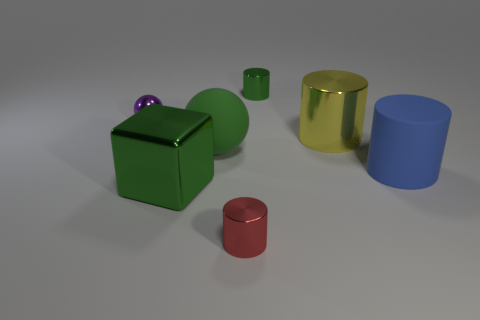How many other things are there of the same material as the large yellow cylinder?
Provide a succinct answer. 4. There is a metallic thing that is the same color as the shiny block; what is its shape?
Your response must be concise. Cylinder. There is a green thing that is on the left side of the big green rubber thing; what is its size?
Keep it short and to the point. Large. There is a purple object that is the same material as the small green object; what shape is it?
Keep it short and to the point. Sphere. Are the yellow cylinder and the sphere to the right of the metallic ball made of the same material?
Offer a terse response. No. Is the shape of the small shiny object that is left of the small red shiny thing the same as  the big green rubber thing?
Keep it short and to the point. Yes. There is another thing that is the same shape as the green rubber object; what is its material?
Make the answer very short. Metal. Do the large yellow metal thing and the tiny shiny object in front of the large green metallic thing have the same shape?
Make the answer very short. Yes. What is the color of the big thing that is on the right side of the green metallic block and to the left of the yellow metallic thing?
Provide a short and direct response. Green. Are any yellow shiny objects visible?
Ensure brevity in your answer.  Yes. 